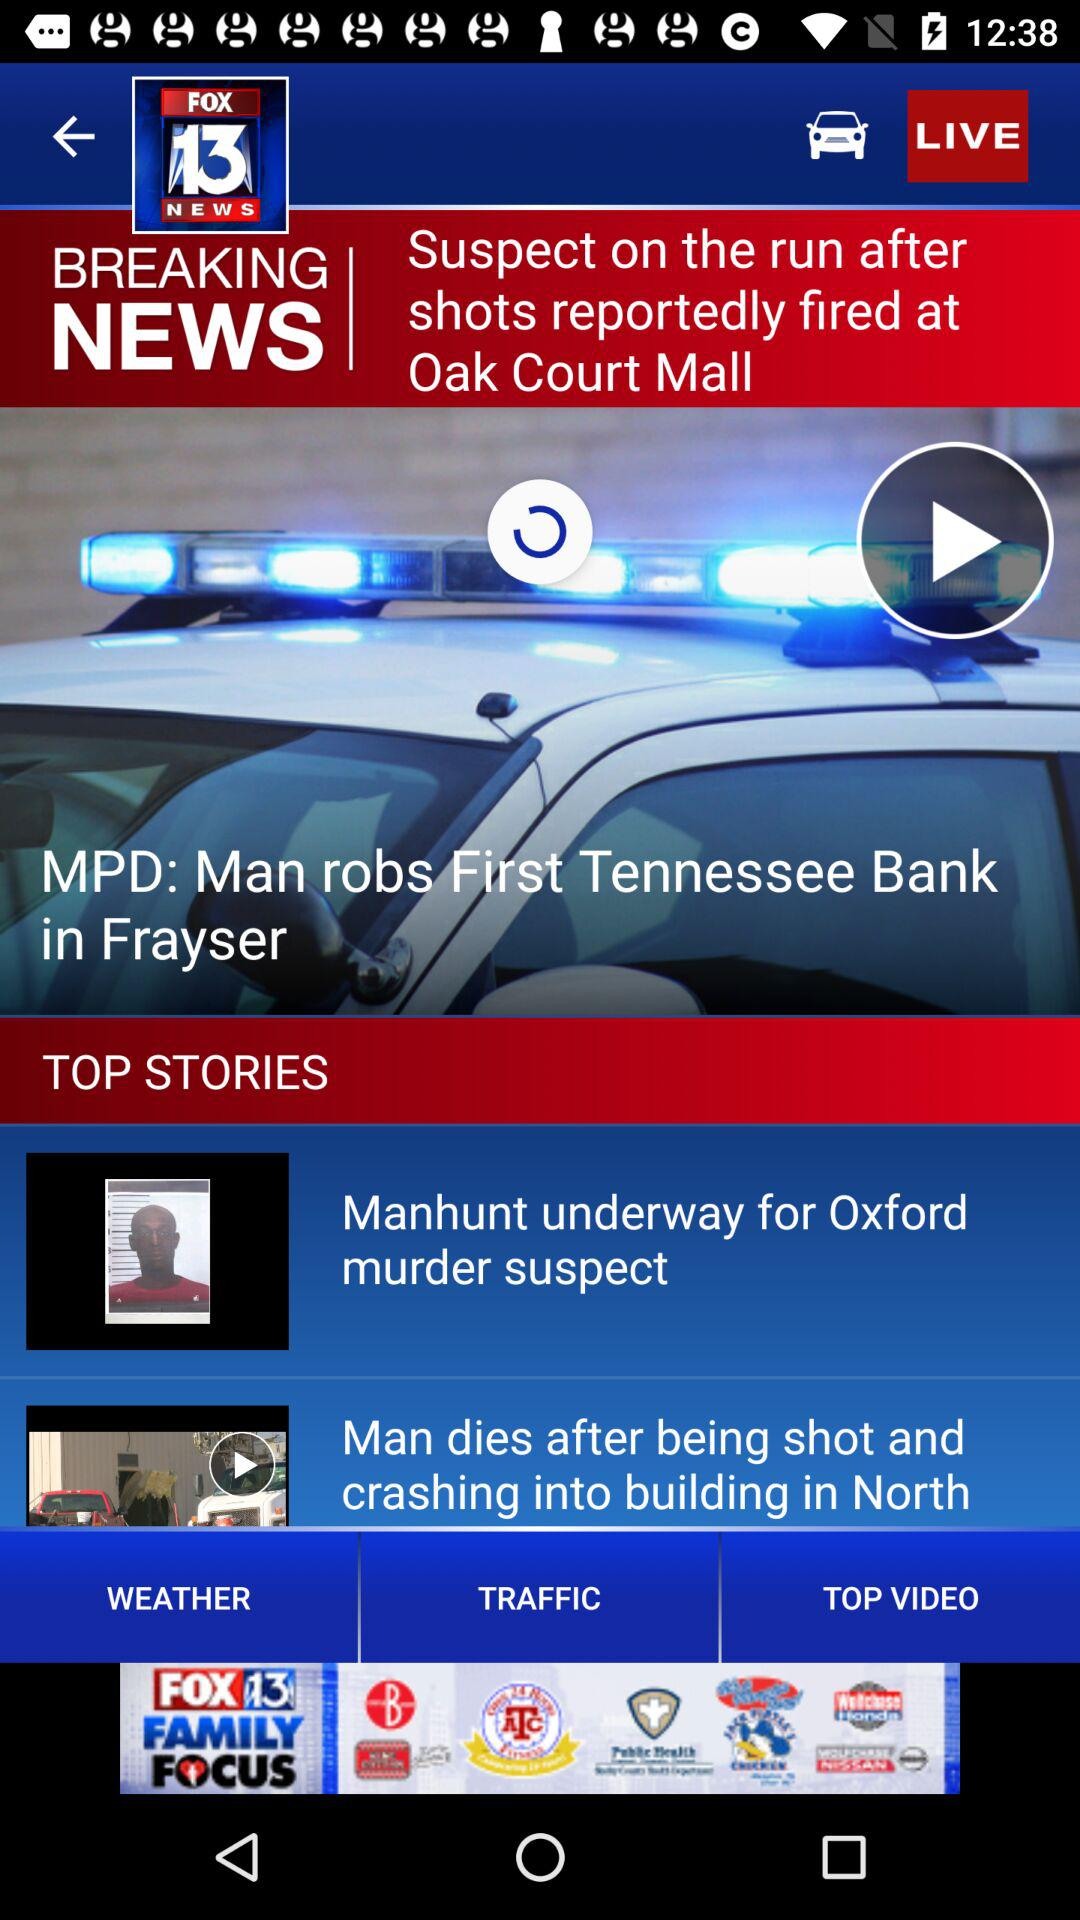Can you tell me some more top stories?
When the provided information is insufficient, respond with <no answer>. <no answer> 